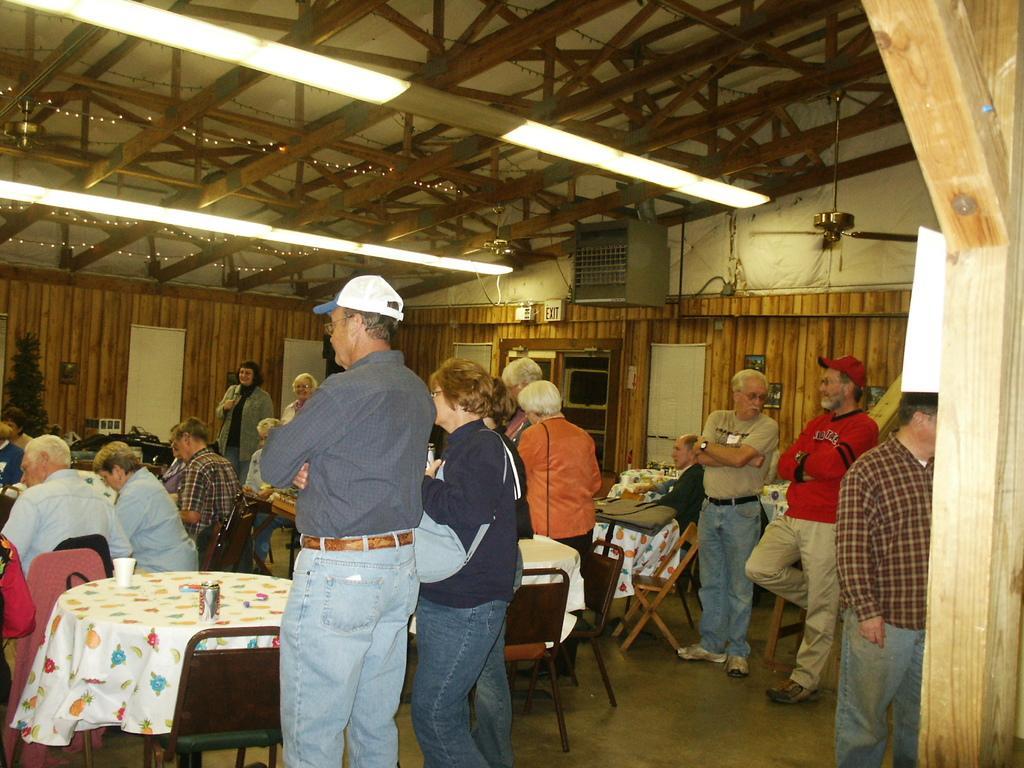Describe this image in one or two sentences. In this image we can see a group of people standing on the floor. We can also see some people sitting on the chairs beside the tables containing some glasses and tins on them. We can also see the window blinds, an ac vent and a signboard. On the top of the image we can see a roof with some ceiling lights, wooden poles and ceiling fans. 